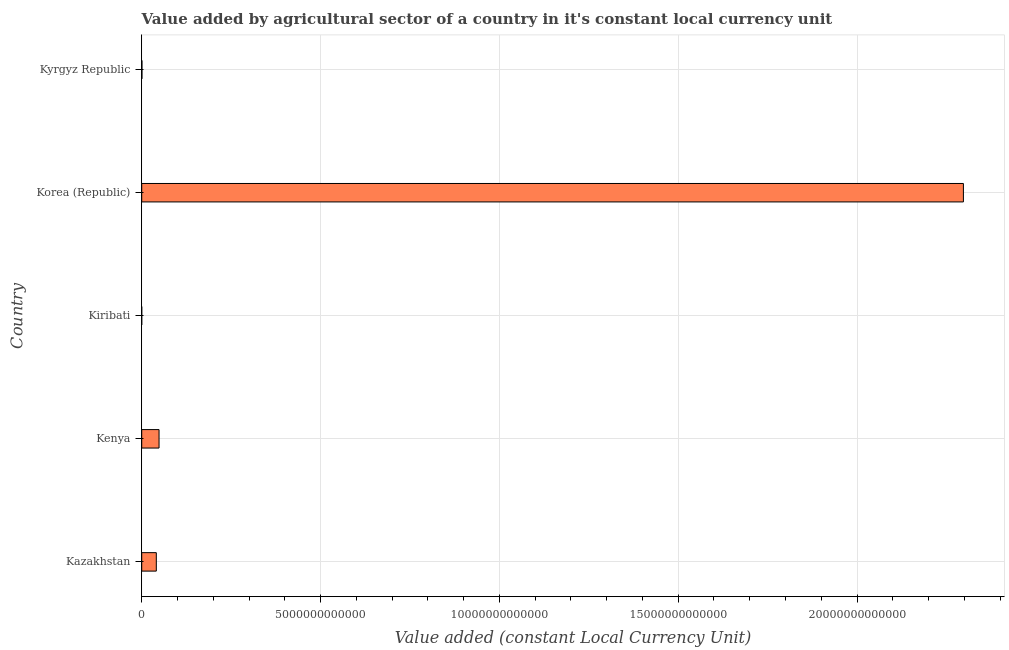Does the graph contain grids?
Provide a succinct answer. Yes. What is the title of the graph?
Keep it short and to the point. Value added by agricultural sector of a country in it's constant local currency unit. What is the label or title of the X-axis?
Your answer should be very brief. Value added (constant Local Currency Unit). What is the label or title of the Y-axis?
Ensure brevity in your answer.  Country. What is the value added by agriculture sector in Korea (Republic)?
Your answer should be compact. 2.30e+13. Across all countries, what is the maximum value added by agriculture sector?
Provide a short and direct response. 2.30e+13. Across all countries, what is the minimum value added by agriculture sector?
Keep it short and to the point. 3.56e+07. In which country was the value added by agriculture sector minimum?
Keep it short and to the point. Kiribati. What is the sum of the value added by agriculture sector?
Offer a terse response. 2.39e+13. What is the difference between the value added by agriculture sector in Kenya and Kyrgyz Republic?
Give a very brief answer. 4.78e+11. What is the average value added by agriculture sector per country?
Offer a terse response. 4.77e+12. What is the median value added by agriculture sector?
Make the answer very short. 4.08e+11. In how many countries, is the value added by agriculture sector greater than 17000000000000 LCU?
Provide a short and direct response. 1. What is the ratio of the value added by agriculture sector in Korea (Republic) to that in Kyrgyz Republic?
Make the answer very short. 3497.93. What is the difference between the highest and the second highest value added by agriculture sector?
Your answer should be very brief. 2.25e+13. Is the sum of the value added by agriculture sector in Kenya and Kiribati greater than the maximum value added by agriculture sector across all countries?
Your answer should be compact. No. What is the difference between the highest and the lowest value added by agriculture sector?
Make the answer very short. 2.30e+13. Are all the bars in the graph horizontal?
Your response must be concise. Yes. How many countries are there in the graph?
Provide a short and direct response. 5. What is the difference between two consecutive major ticks on the X-axis?
Keep it short and to the point. 5.00e+12. Are the values on the major ticks of X-axis written in scientific E-notation?
Provide a succinct answer. No. What is the Value added (constant Local Currency Unit) in Kazakhstan?
Your answer should be very brief. 4.08e+11. What is the Value added (constant Local Currency Unit) in Kenya?
Make the answer very short. 4.84e+11. What is the Value added (constant Local Currency Unit) in Kiribati?
Provide a short and direct response. 3.56e+07. What is the Value added (constant Local Currency Unit) in Korea (Republic)?
Keep it short and to the point. 2.30e+13. What is the Value added (constant Local Currency Unit) in Kyrgyz Republic?
Make the answer very short. 6.57e+09. What is the difference between the Value added (constant Local Currency Unit) in Kazakhstan and Kenya?
Make the answer very short. -7.65e+1. What is the difference between the Value added (constant Local Currency Unit) in Kazakhstan and Kiribati?
Make the answer very short. 4.08e+11. What is the difference between the Value added (constant Local Currency Unit) in Kazakhstan and Korea (Republic)?
Your response must be concise. -2.26e+13. What is the difference between the Value added (constant Local Currency Unit) in Kazakhstan and Kyrgyz Republic?
Keep it short and to the point. 4.01e+11. What is the difference between the Value added (constant Local Currency Unit) in Kenya and Kiribati?
Provide a succinct answer. 4.84e+11. What is the difference between the Value added (constant Local Currency Unit) in Kenya and Korea (Republic)?
Your answer should be compact. -2.25e+13. What is the difference between the Value added (constant Local Currency Unit) in Kenya and Kyrgyz Republic?
Make the answer very short. 4.78e+11. What is the difference between the Value added (constant Local Currency Unit) in Kiribati and Korea (Republic)?
Offer a very short reply. -2.30e+13. What is the difference between the Value added (constant Local Currency Unit) in Kiribati and Kyrgyz Republic?
Your answer should be very brief. -6.53e+09. What is the difference between the Value added (constant Local Currency Unit) in Korea (Republic) and Kyrgyz Republic?
Your response must be concise. 2.30e+13. What is the ratio of the Value added (constant Local Currency Unit) in Kazakhstan to that in Kenya?
Provide a succinct answer. 0.84. What is the ratio of the Value added (constant Local Currency Unit) in Kazakhstan to that in Kiribati?
Make the answer very short. 1.15e+04. What is the ratio of the Value added (constant Local Currency Unit) in Kazakhstan to that in Korea (Republic)?
Your response must be concise. 0.02. What is the ratio of the Value added (constant Local Currency Unit) in Kazakhstan to that in Kyrgyz Republic?
Keep it short and to the point. 62.09. What is the ratio of the Value added (constant Local Currency Unit) in Kenya to that in Kiribati?
Your answer should be compact. 1.36e+04. What is the ratio of the Value added (constant Local Currency Unit) in Kenya to that in Korea (Republic)?
Give a very brief answer. 0.02. What is the ratio of the Value added (constant Local Currency Unit) in Kenya to that in Kyrgyz Republic?
Make the answer very short. 73.73. What is the ratio of the Value added (constant Local Currency Unit) in Kiribati to that in Kyrgyz Republic?
Your answer should be compact. 0.01. What is the ratio of the Value added (constant Local Currency Unit) in Korea (Republic) to that in Kyrgyz Republic?
Provide a short and direct response. 3497.93. 